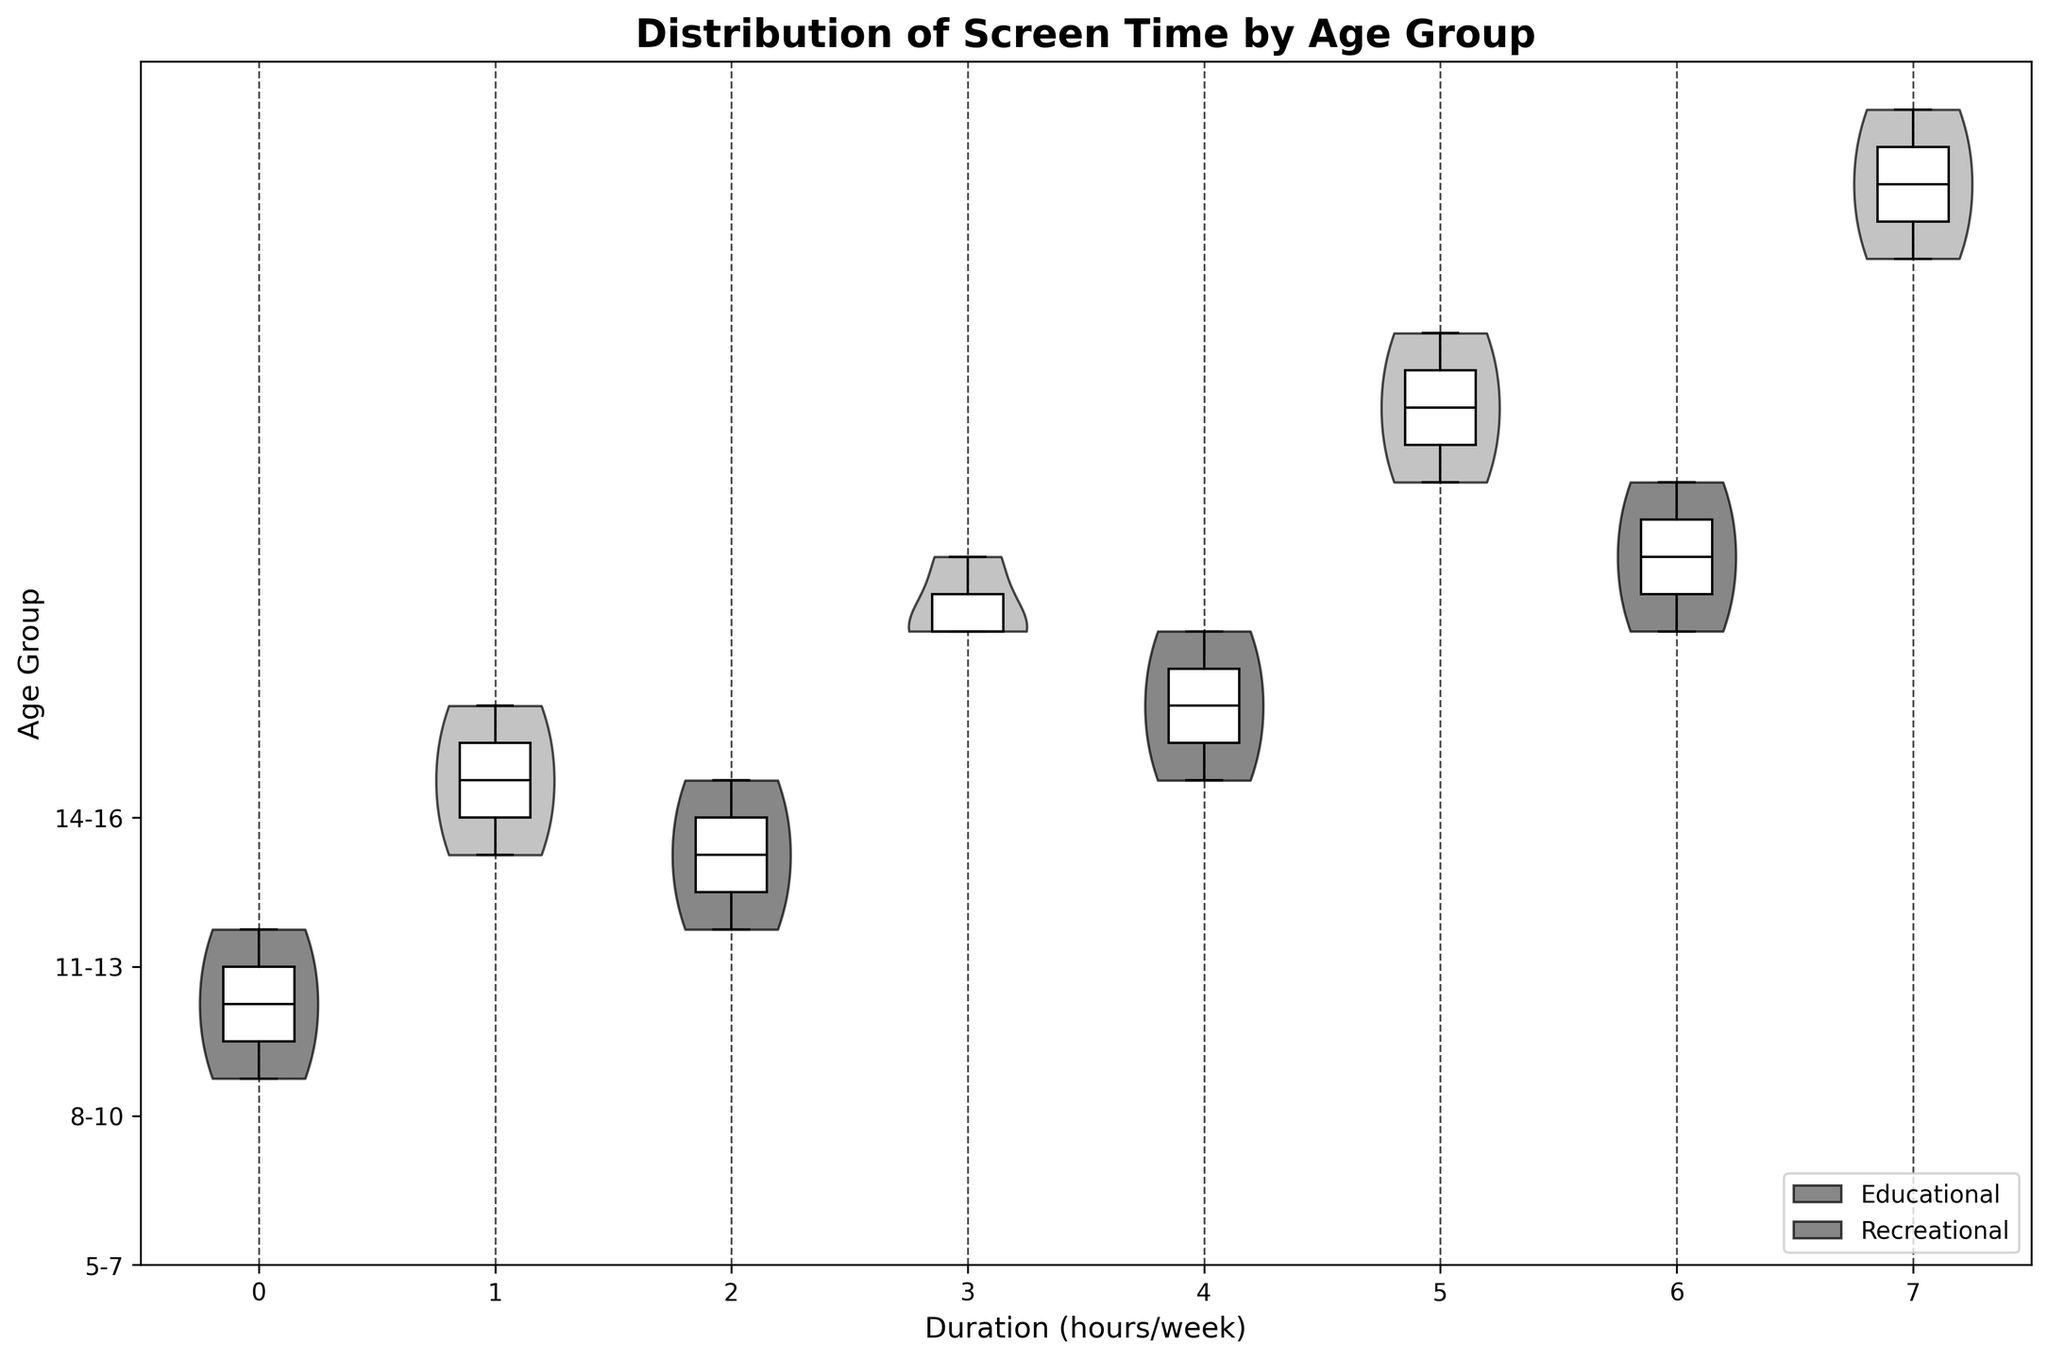What is the title of the figure? The title is displayed at the top of the figure and it describes what the figure is about. In this case, it should summarize the content of the chart.
Answer: Distribution of Screen Time by Age Group Which age group has the highest median duration for recreational screen time? To find the highest median for recreational screen time, look for the yellowish (recreational) violin plot with the highest median line across all age groups.
Answer: 14-16 How does the median educational screen time compare between the 8-10 and 11-13 age groups? Compare the median lines on the white box plots within each violin for educational screen time in the 8-10 and 11-13 age groups.
Answer: Higher in 11-13 What is the range of recreational screen time for the 5-7 age group? The range can be determined by identifying the minimum and maximum whiskers on the box plot within the recreational screen time (yellowish violin plot) for the 5-7 age group.
Answer: 6-8 hours per week Which type of screen time has a wider distribution in the 14-16 age group? To determine which type has a wider distribution, compare the widths of the educational (gray) and recreational (yellowish) violin plots for the 14-16 age group.
Answer: Recreational What is the average median screen time (educational and recreational) across all age groups? Find the median values for each age group and for both educational and recreational screen times, sum them up, and then divide by the total number of medians.
Answer: 9 hours per week How does the variability in screen time compare between educational and recreational activities for the 11-13 age group? Compare the shapes and widths of the educational (gray) and recreational (yellowish) violin plots for the 11-13 age group to assess variability.
Answer: Higher for recreational Are there any age groups where the median educational screen time equals the median recreational screen time? Look for groups where the educational (gray) and recreational (yellowish) violin plots have median lines at the same position.
Answer: No How does the educational screen time for the youngest age group (5-7) compare to the oldest age group (14-16)? Compare the locations of the gray violin plots for the 5-7 and 14-16 age groups to see the difference in educational screen time.
Answer: Less in 5-7 What can you infer about the trend of recreational screen time as children get older? Examine the position and shape changes of the recreational (yellowish) violin plots across increasing age groups.
Answer: Recreational time increases 